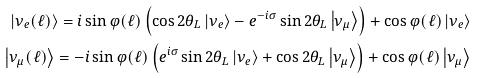<formula> <loc_0><loc_0><loc_500><loc_500>\left | \nu _ { e } ( \ell ) \right > = i \sin \varphi ( \ell ) \left ( \cos 2 \theta _ { L } \left | \nu _ { e } \right > - e ^ { - i \sigma } \sin 2 \theta _ { L } \left | \nu _ { \mu } \right > \right ) + \cos \varphi ( \ell ) \left | \nu _ { e } \right > \\ \left | \nu _ { \mu } ( \ell ) \right > = - i \sin \varphi ( \ell ) \left ( e ^ { i \sigma } \sin 2 \theta _ { L } \left | \nu _ { e } \right > + \cos 2 \theta _ { L } \left | \nu _ { \mu } \right > \right ) + \cos \varphi ( \ell ) \left | \nu _ { \mu } \right ></formula> 